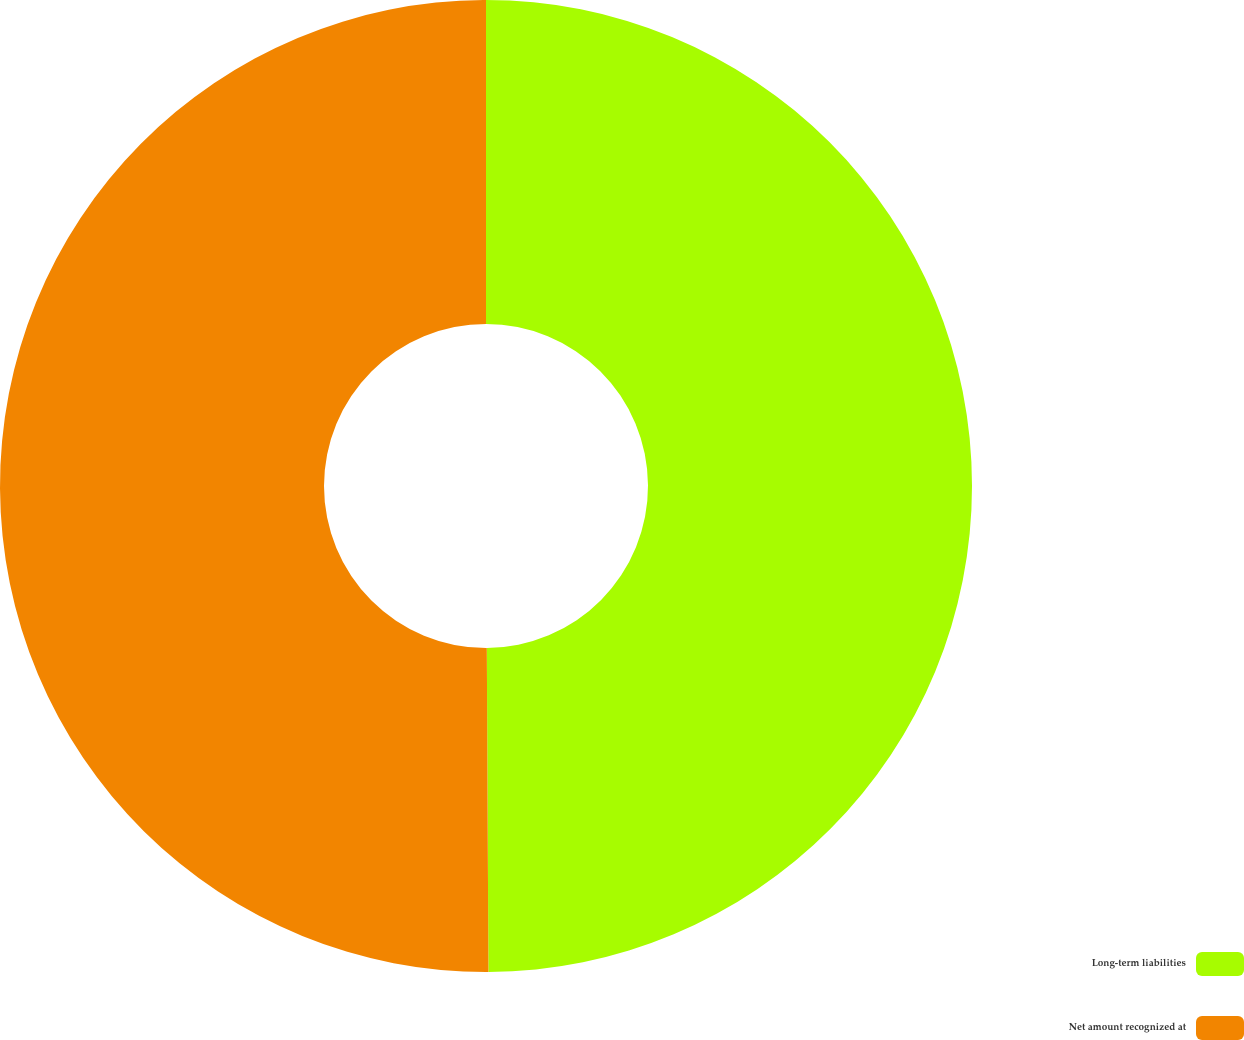Convert chart to OTSL. <chart><loc_0><loc_0><loc_500><loc_500><pie_chart><fcel>Long-term liabilities<fcel>Net amount recognized at<nl><fcel>49.92%<fcel>50.08%<nl></chart> 